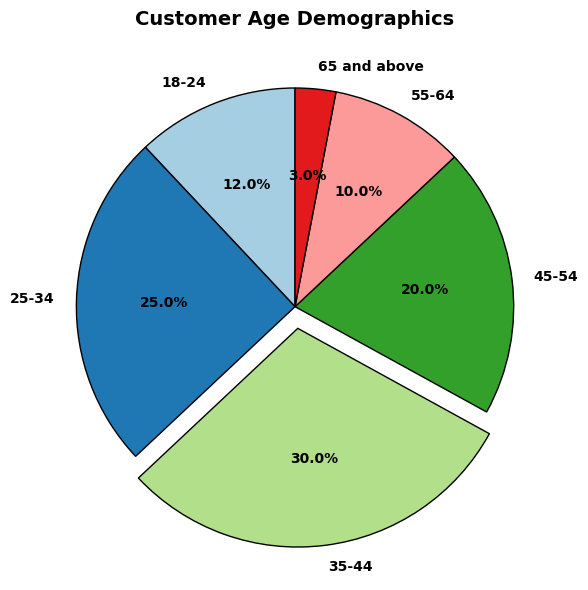What's the percentage of customers in the 18-24 age group? The pie chart shows the percentage distributions directly. Look for the segment labeled '18-24'.
Answer: 12% What's the sum of the percentages of customers aged 35 and above? Sum the percentages for the age groups 35-44 (30%), 45-54 (20%), 55-64 (10%), and 65 and above (3%). 30 + 20 + 10 + 3 = 63
Answer: 63% Which age group has the largest percentage of customers? The largest segment will have the highest percentage label. The segment labeled '35-44' shows 30%, which is the largest.
Answer: 35-44 How does the percentage of the 25-34 age group compare to that of the 45-54 age group? Look at the percentages for both age groups. The '25-34' group has 25% and the '45-54' group has 20%. Compare these values to see that 25% is greater than 20%.
Answer: 25-34 has a higher percentage Which age group has the smallest percentage of customers? Look for the smallest segment. The segment labeled '65 and above' with 3% is the smallest.
Answer: 65 and above What's the difference in percentage between the 35-44 and 55-64 age groups? Subtract the percentage of the '55-64' age group (10%) from the '35-44' age group (30%). 30 - 10 = 20
Answer: 20 What percentage of customers are younger than 35? Add the percentages for the '18-24' (12%) and '25-34' (25%) age groups. 12 + 25 = 37
Answer: 37% How does the combined percentage of customers aged 18-24 and 65 and above compare to that of the 45-54 age group? Add the percentages for '18-24' (12%) and '65 and above' (3%) and compare with '45-54' (20%). 12 + 3 = 15; since 15 is less than 20, the combined percentage is smaller.
Answer: Combined is smaller What's the visual effect applied to the 35-44 age group segment? Observe the pie chart carefully. The '35-44' segment is slightly separated from the rest, indicating an "explode" effect.
Answer: Exploded Which age groups together make up more than half of the customers? Add percentages sequentially and check if the cumulative total exceeds 50%. '35-44' (30%) and '25-34' (25%) together sum to 55%, which is more than half.
Answer: 35-44 and 25-34 